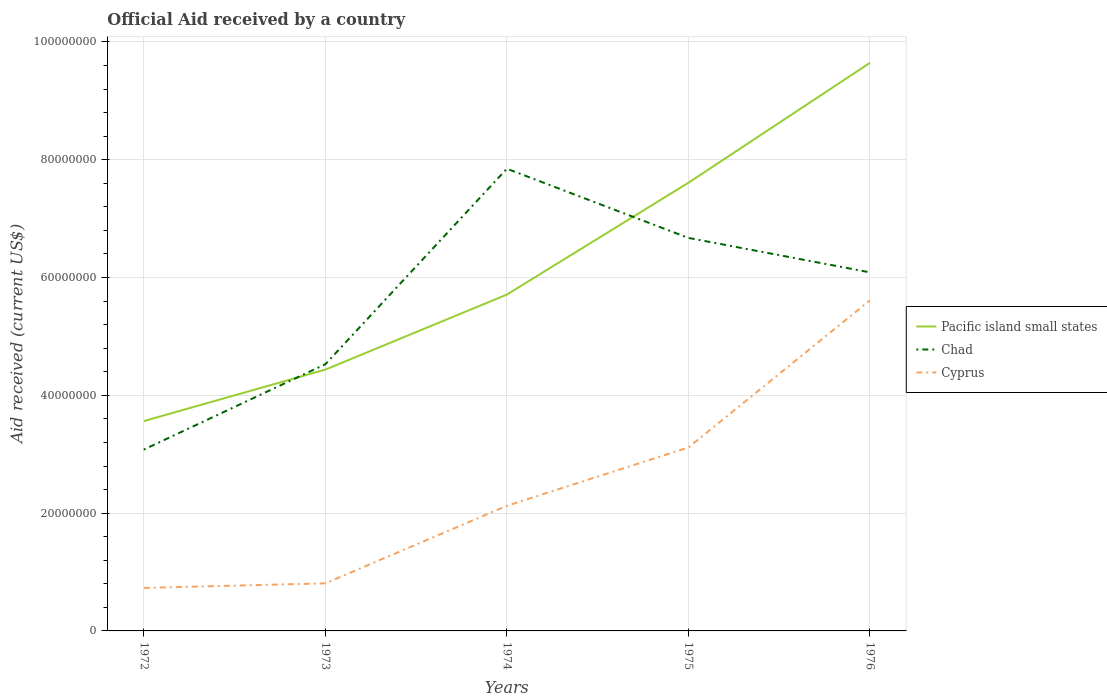How many different coloured lines are there?
Offer a terse response. 3. Does the line corresponding to Pacific island small states intersect with the line corresponding to Cyprus?
Ensure brevity in your answer.  No. Is the number of lines equal to the number of legend labels?
Give a very brief answer. Yes. Across all years, what is the maximum net official aid received in Chad?
Provide a succinct answer. 3.08e+07. What is the total net official aid received in Pacific island small states in the graph?
Make the answer very short. -3.94e+07. What is the difference between the highest and the second highest net official aid received in Chad?
Your answer should be compact. 4.77e+07. Is the net official aid received in Pacific island small states strictly greater than the net official aid received in Chad over the years?
Your response must be concise. No. How many lines are there?
Your answer should be compact. 3. What is the difference between two consecutive major ticks on the Y-axis?
Offer a terse response. 2.00e+07. Does the graph contain grids?
Provide a succinct answer. Yes. How are the legend labels stacked?
Ensure brevity in your answer.  Vertical. What is the title of the graph?
Provide a short and direct response. Official Aid received by a country. What is the label or title of the X-axis?
Provide a succinct answer. Years. What is the label or title of the Y-axis?
Your answer should be very brief. Aid received (current US$). What is the Aid received (current US$) in Pacific island small states in 1972?
Ensure brevity in your answer.  3.56e+07. What is the Aid received (current US$) in Chad in 1972?
Make the answer very short. 3.08e+07. What is the Aid received (current US$) in Cyprus in 1972?
Ensure brevity in your answer.  7.30e+06. What is the Aid received (current US$) of Pacific island small states in 1973?
Offer a terse response. 4.44e+07. What is the Aid received (current US$) of Chad in 1973?
Keep it short and to the point. 4.53e+07. What is the Aid received (current US$) in Cyprus in 1973?
Give a very brief answer. 8.08e+06. What is the Aid received (current US$) of Pacific island small states in 1974?
Provide a short and direct response. 5.71e+07. What is the Aid received (current US$) in Chad in 1974?
Provide a short and direct response. 7.85e+07. What is the Aid received (current US$) in Cyprus in 1974?
Offer a very short reply. 2.12e+07. What is the Aid received (current US$) in Pacific island small states in 1975?
Provide a succinct answer. 7.61e+07. What is the Aid received (current US$) of Chad in 1975?
Provide a succinct answer. 6.67e+07. What is the Aid received (current US$) in Cyprus in 1975?
Your answer should be compact. 3.12e+07. What is the Aid received (current US$) in Pacific island small states in 1976?
Your answer should be very brief. 9.65e+07. What is the Aid received (current US$) in Chad in 1976?
Provide a succinct answer. 6.09e+07. What is the Aid received (current US$) in Cyprus in 1976?
Your answer should be very brief. 5.61e+07. Across all years, what is the maximum Aid received (current US$) of Pacific island small states?
Your answer should be very brief. 9.65e+07. Across all years, what is the maximum Aid received (current US$) in Chad?
Ensure brevity in your answer.  7.85e+07. Across all years, what is the maximum Aid received (current US$) in Cyprus?
Your answer should be very brief. 5.61e+07. Across all years, what is the minimum Aid received (current US$) in Pacific island small states?
Offer a terse response. 3.56e+07. Across all years, what is the minimum Aid received (current US$) in Chad?
Your answer should be very brief. 3.08e+07. Across all years, what is the minimum Aid received (current US$) of Cyprus?
Give a very brief answer. 7.30e+06. What is the total Aid received (current US$) of Pacific island small states in the graph?
Give a very brief answer. 3.10e+08. What is the total Aid received (current US$) of Chad in the graph?
Provide a short and direct response. 2.82e+08. What is the total Aid received (current US$) of Cyprus in the graph?
Offer a very short reply. 1.24e+08. What is the difference between the Aid received (current US$) in Pacific island small states in 1972 and that in 1973?
Keep it short and to the point. -8.74e+06. What is the difference between the Aid received (current US$) of Chad in 1972 and that in 1973?
Your answer should be very brief. -1.45e+07. What is the difference between the Aid received (current US$) in Cyprus in 1972 and that in 1973?
Your response must be concise. -7.80e+05. What is the difference between the Aid received (current US$) of Pacific island small states in 1972 and that in 1974?
Ensure brevity in your answer.  -2.15e+07. What is the difference between the Aid received (current US$) of Chad in 1972 and that in 1974?
Provide a succinct answer. -4.77e+07. What is the difference between the Aid received (current US$) of Cyprus in 1972 and that in 1974?
Your response must be concise. -1.40e+07. What is the difference between the Aid received (current US$) in Pacific island small states in 1972 and that in 1975?
Your response must be concise. -4.05e+07. What is the difference between the Aid received (current US$) of Chad in 1972 and that in 1975?
Provide a short and direct response. -3.59e+07. What is the difference between the Aid received (current US$) of Cyprus in 1972 and that in 1975?
Provide a short and direct response. -2.38e+07. What is the difference between the Aid received (current US$) in Pacific island small states in 1972 and that in 1976?
Your response must be concise. -6.08e+07. What is the difference between the Aid received (current US$) in Chad in 1972 and that in 1976?
Provide a succinct answer. -3.01e+07. What is the difference between the Aid received (current US$) of Cyprus in 1972 and that in 1976?
Provide a succinct answer. -4.88e+07. What is the difference between the Aid received (current US$) in Pacific island small states in 1973 and that in 1974?
Make the answer very short. -1.27e+07. What is the difference between the Aid received (current US$) in Chad in 1973 and that in 1974?
Offer a terse response. -3.32e+07. What is the difference between the Aid received (current US$) of Cyprus in 1973 and that in 1974?
Give a very brief answer. -1.32e+07. What is the difference between the Aid received (current US$) of Pacific island small states in 1973 and that in 1975?
Your response must be concise. -3.17e+07. What is the difference between the Aid received (current US$) of Chad in 1973 and that in 1975?
Your answer should be very brief. -2.14e+07. What is the difference between the Aid received (current US$) in Cyprus in 1973 and that in 1975?
Your response must be concise. -2.31e+07. What is the difference between the Aid received (current US$) in Pacific island small states in 1973 and that in 1976?
Provide a succinct answer. -5.21e+07. What is the difference between the Aid received (current US$) in Chad in 1973 and that in 1976?
Your answer should be compact. -1.56e+07. What is the difference between the Aid received (current US$) of Cyprus in 1973 and that in 1976?
Your answer should be very brief. -4.81e+07. What is the difference between the Aid received (current US$) in Pacific island small states in 1974 and that in 1975?
Provide a short and direct response. -1.90e+07. What is the difference between the Aid received (current US$) in Chad in 1974 and that in 1975?
Ensure brevity in your answer.  1.18e+07. What is the difference between the Aid received (current US$) in Cyprus in 1974 and that in 1975?
Your response must be concise. -9.90e+06. What is the difference between the Aid received (current US$) in Pacific island small states in 1974 and that in 1976?
Your answer should be compact. -3.94e+07. What is the difference between the Aid received (current US$) of Chad in 1974 and that in 1976?
Offer a terse response. 1.76e+07. What is the difference between the Aid received (current US$) of Cyprus in 1974 and that in 1976?
Your answer should be compact. -3.49e+07. What is the difference between the Aid received (current US$) of Pacific island small states in 1975 and that in 1976?
Your answer should be very brief. -2.04e+07. What is the difference between the Aid received (current US$) of Chad in 1975 and that in 1976?
Keep it short and to the point. 5.85e+06. What is the difference between the Aid received (current US$) of Cyprus in 1975 and that in 1976?
Give a very brief answer. -2.50e+07. What is the difference between the Aid received (current US$) of Pacific island small states in 1972 and the Aid received (current US$) of Chad in 1973?
Keep it short and to the point. -9.65e+06. What is the difference between the Aid received (current US$) in Pacific island small states in 1972 and the Aid received (current US$) in Cyprus in 1973?
Ensure brevity in your answer.  2.76e+07. What is the difference between the Aid received (current US$) in Chad in 1972 and the Aid received (current US$) in Cyprus in 1973?
Offer a terse response. 2.27e+07. What is the difference between the Aid received (current US$) in Pacific island small states in 1972 and the Aid received (current US$) in Chad in 1974?
Provide a succinct answer. -4.28e+07. What is the difference between the Aid received (current US$) in Pacific island small states in 1972 and the Aid received (current US$) in Cyprus in 1974?
Give a very brief answer. 1.44e+07. What is the difference between the Aid received (current US$) of Chad in 1972 and the Aid received (current US$) of Cyprus in 1974?
Offer a very short reply. 9.54e+06. What is the difference between the Aid received (current US$) in Pacific island small states in 1972 and the Aid received (current US$) in Chad in 1975?
Make the answer very short. -3.11e+07. What is the difference between the Aid received (current US$) of Pacific island small states in 1972 and the Aid received (current US$) of Cyprus in 1975?
Ensure brevity in your answer.  4.48e+06. What is the difference between the Aid received (current US$) in Chad in 1972 and the Aid received (current US$) in Cyprus in 1975?
Offer a terse response. -3.60e+05. What is the difference between the Aid received (current US$) of Pacific island small states in 1972 and the Aid received (current US$) of Chad in 1976?
Your answer should be compact. -2.52e+07. What is the difference between the Aid received (current US$) of Pacific island small states in 1972 and the Aid received (current US$) of Cyprus in 1976?
Offer a very short reply. -2.05e+07. What is the difference between the Aid received (current US$) in Chad in 1972 and the Aid received (current US$) in Cyprus in 1976?
Provide a succinct answer. -2.54e+07. What is the difference between the Aid received (current US$) in Pacific island small states in 1973 and the Aid received (current US$) in Chad in 1974?
Give a very brief answer. -3.41e+07. What is the difference between the Aid received (current US$) of Pacific island small states in 1973 and the Aid received (current US$) of Cyprus in 1974?
Provide a short and direct response. 2.31e+07. What is the difference between the Aid received (current US$) of Chad in 1973 and the Aid received (current US$) of Cyprus in 1974?
Your answer should be compact. 2.40e+07. What is the difference between the Aid received (current US$) in Pacific island small states in 1973 and the Aid received (current US$) in Chad in 1975?
Give a very brief answer. -2.24e+07. What is the difference between the Aid received (current US$) of Pacific island small states in 1973 and the Aid received (current US$) of Cyprus in 1975?
Your answer should be compact. 1.32e+07. What is the difference between the Aid received (current US$) in Chad in 1973 and the Aid received (current US$) in Cyprus in 1975?
Give a very brief answer. 1.41e+07. What is the difference between the Aid received (current US$) in Pacific island small states in 1973 and the Aid received (current US$) in Chad in 1976?
Give a very brief answer. -1.65e+07. What is the difference between the Aid received (current US$) in Pacific island small states in 1973 and the Aid received (current US$) in Cyprus in 1976?
Give a very brief answer. -1.18e+07. What is the difference between the Aid received (current US$) of Chad in 1973 and the Aid received (current US$) of Cyprus in 1976?
Your answer should be compact. -1.09e+07. What is the difference between the Aid received (current US$) in Pacific island small states in 1974 and the Aid received (current US$) in Chad in 1975?
Provide a succinct answer. -9.62e+06. What is the difference between the Aid received (current US$) in Pacific island small states in 1974 and the Aid received (current US$) in Cyprus in 1975?
Ensure brevity in your answer.  2.60e+07. What is the difference between the Aid received (current US$) in Chad in 1974 and the Aid received (current US$) in Cyprus in 1975?
Your answer should be compact. 4.73e+07. What is the difference between the Aid received (current US$) in Pacific island small states in 1974 and the Aid received (current US$) in Chad in 1976?
Provide a succinct answer. -3.77e+06. What is the difference between the Aid received (current US$) in Pacific island small states in 1974 and the Aid received (current US$) in Cyprus in 1976?
Your response must be concise. 9.70e+05. What is the difference between the Aid received (current US$) of Chad in 1974 and the Aid received (current US$) of Cyprus in 1976?
Your answer should be very brief. 2.23e+07. What is the difference between the Aid received (current US$) of Pacific island small states in 1975 and the Aid received (current US$) of Chad in 1976?
Keep it short and to the point. 1.52e+07. What is the difference between the Aid received (current US$) of Pacific island small states in 1975 and the Aid received (current US$) of Cyprus in 1976?
Your answer should be compact. 2.00e+07. What is the difference between the Aid received (current US$) of Chad in 1975 and the Aid received (current US$) of Cyprus in 1976?
Offer a terse response. 1.06e+07. What is the average Aid received (current US$) in Pacific island small states per year?
Give a very brief answer. 6.19e+07. What is the average Aid received (current US$) of Chad per year?
Keep it short and to the point. 5.64e+07. What is the average Aid received (current US$) of Cyprus per year?
Your answer should be very brief. 2.48e+07. In the year 1972, what is the difference between the Aid received (current US$) in Pacific island small states and Aid received (current US$) in Chad?
Make the answer very short. 4.84e+06. In the year 1972, what is the difference between the Aid received (current US$) in Pacific island small states and Aid received (current US$) in Cyprus?
Ensure brevity in your answer.  2.83e+07. In the year 1972, what is the difference between the Aid received (current US$) in Chad and Aid received (current US$) in Cyprus?
Provide a succinct answer. 2.35e+07. In the year 1973, what is the difference between the Aid received (current US$) of Pacific island small states and Aid received (current US$) of Chad?
Your answer should be compact. -9.10e+05. In the year 1973, what is the difference between the Aid received (current US$) in Pacific island small states and Aid received (current US$) in Cyprus?
Keep it short and to the point. 3.63e+07. In the year 1973, what is the difference between the Aid received (current US$) in Chad and Aid received (current US$) in Cyprus?
Ensure brevity in your answer.  3.72e+07. In the year 1974, what is the difference between the Aid received (current US$) in Pacific island small states and Aid received (current US$) in Chad?
Your answer should be very brief. -2.14e+07. In the year 1974, what is the difference between the Aid received (current US$) of Pacific island small states and Aid received (current US$) of Cyprus?
Give a very brief answer. 3.59e+07. In the year 1974, what is the difference between the Aid received (current US$) in Chad and Aid received (current US$) in Cyprus?
Make the answer very short. 5.72e+07. In the year 1975, what is the difference between the Aid received (current US$) in Pacific island small states and Aid received (current US$) in Chad?
Your answer should be compact. 9.37e+06. In the year 1975, what is the difference between the Aid received (current US$) of Pacific island small states and Aid received (current US$) of Cyprus?
Provide a short and direct response. 4.50e+07. In the year 1975, what is the difference between the Aid received (current US$) of Chad and Aid received (current US$) of Cyprus?
Give a very brief answer. 3.56e+07. In the year 1976, what is the difference between the Aid received (current US$) in Pacific island small states and Aid received (current US$) in Chad?
Your answer should be compact. 3.56e+07. In the year 1976, what is the difference between the Aid received (current US$) in Pacific island small states and Aid received (current US$) in Cyprus?
Your response must be concise. 4.03e+07. In the year 1976, what is the difference between the Aid received (current US$) in Chad and Aid received (current US$) in Cyprus?
Your answer should be very brief. 4.74e+06. What is the ratio of the Aid received (current US$) of Pacific island small states in 1972 to that in 1973?
Provide a short and direct response. 0.8. What is the ratio of the Aid received (current US$) in Chad in 1972 to that in 1973?
Your answer should be very brief. 0.68. What is the ratio of the Aid received (current US$) in Cyprus in 1972 to that in 1973?
Provide a short and direct response. 0.9. What is the ratio of the Aid received (current US$) in Pacific island small states in 1972 to that in 1974?
Your answer should be compact. 0.62. What is the ratio of the Aid received (current US$) of Chad in 1972 to that in 1974?
Give a very brief answer. 0.39. What is the ratio of the Aid received (current US$) in Cyprus in 1972 to that in 1974?
Offer a very short reply. 0.34. What is the ratio of the Aid received (current US$) of Pacific island small states in 1972 to that in 1975?
Keep it short and to the point. 0.47. What is the ratio of the Aid received (current US$) in Chad in 1972 to that in 1975?
Offer a very short reply. 0.46. What is the ratio of the Aid received (current US$) in Cyprus in 1972 to that in 1975?
Your answer should be compact. 0.23. What is the ratio of the Aid received (current US$) of Pacific island small states in 1972 to that in 1976?
Your response must be concise. 0.37. What is the ratio of the Aid received (current US$) in Chad in 1972 to that in 1976?
Make the answer very short. 0.51. What is the ratio of the Aid received (current US$) in Cyprus in 1972 to that in 1976?
Offer a very short reply. 0.13. What is the ratio of the Aid received (current US$) in Pacific island small states in 1973 to that in 1974?
Provide a short and direct response. 0.78. What is the ratio of the Aid received (current US$) of Chad in 1973 to that in 1974?
Provide a succinct answer. 0.58. What is the ratio of the Aid received (current US$) in Cyprus in 1973 to that in 1974?
Provide a succinct answer. 0.38. What is the ratio of the Aid received (current US$) of Pacific island small states in 1973 to that in 1975?
Ensure brevity in your answer.  0.58. What is the ratio of the Aid received (current US$) of Chad in 1973 to that in 1975?
Keep it short and to the point. 0.68. What is the ratio of the Aid received (current US$) of Cyprus in 1973 to that in 1975?
Provide a succinct answer. 0.26. What is the ratio of the Aid received (current US$) in Pacific island small states in 1973 to that in 1976?
Offer a terse response. 0.46. What is the ratio of the Aid received (current US$) of Chad in 1973 to that in 1976?
Keep it short and to the point. 0.74. What is the ratio of the Aid received (current US$) of Cyprus in 1973 to that in 1976?
Ensure brevity in your answer.  0.14. What is the ratio of the Aid received (current US$) of Pacific island small states in 1974 to that in 1975?
Provide a succinct answer. 0.75. What is the ratio of the Aid received (current US$) in Chad in 1974 to that in 1975?
Keep it short and to the point. 1.18. What is the ratio of the Aid received (current US$) in Cyprus in 1974 to that in 1975?
Offer a very short reply. 0.68. What is the ratio of the Aid received (current US$) in Pacific island small states in 1974 to that in 1976?
Your answer should be compact. 0.59. What is the ratio of the Aid received (current US$) in Chad in 1974 to that in 1976?
Give a very brief answer. 1.29. What is the ratio of the Aid received (current US$) of Cyprus in 1974 to that in 1976?
Make the answer very short. 0.38. What is the ratio of the Aid received (current US$) in Pacific island small states in 1975 to that in 1976?
Offer a terse response. 0.79. What is the ratio of the Aid received (current US$) in Chad in 1975 to that in 1976?
Provide a short and direct response. 1.1. What is the ratio of the Aid received (current US$) of Cyprus in 1975 to that in 1976?
Make the answer very short. 0.55. What is the difference between the highest and the second highest Aid received (current US$) in Pacific island small states?
Keep it short and to the point. 2.04e+07. What is the difference between the highest and the second highest Aid received (current US$) in Chad?
Provide a succinct answer. 1.18e+07. What is the difference between the highest and the second highest Aid received (current US$) in Cyprus?
Provide a succinct answer. 2.50e+07. What is the difference between the highest and the lowest Aid received (current US$) in Pacific island small states?
Keep it short and to the point. 6.08e+07. What is the difference between the highest and the lowest Aid received (current US$) in Chad?
Make the answer very short. 4.77e+07. What is the difference between the highest and the lowest Aid received (current US$) of Cyprus?
Make the answer very short. 4.88e+07. 